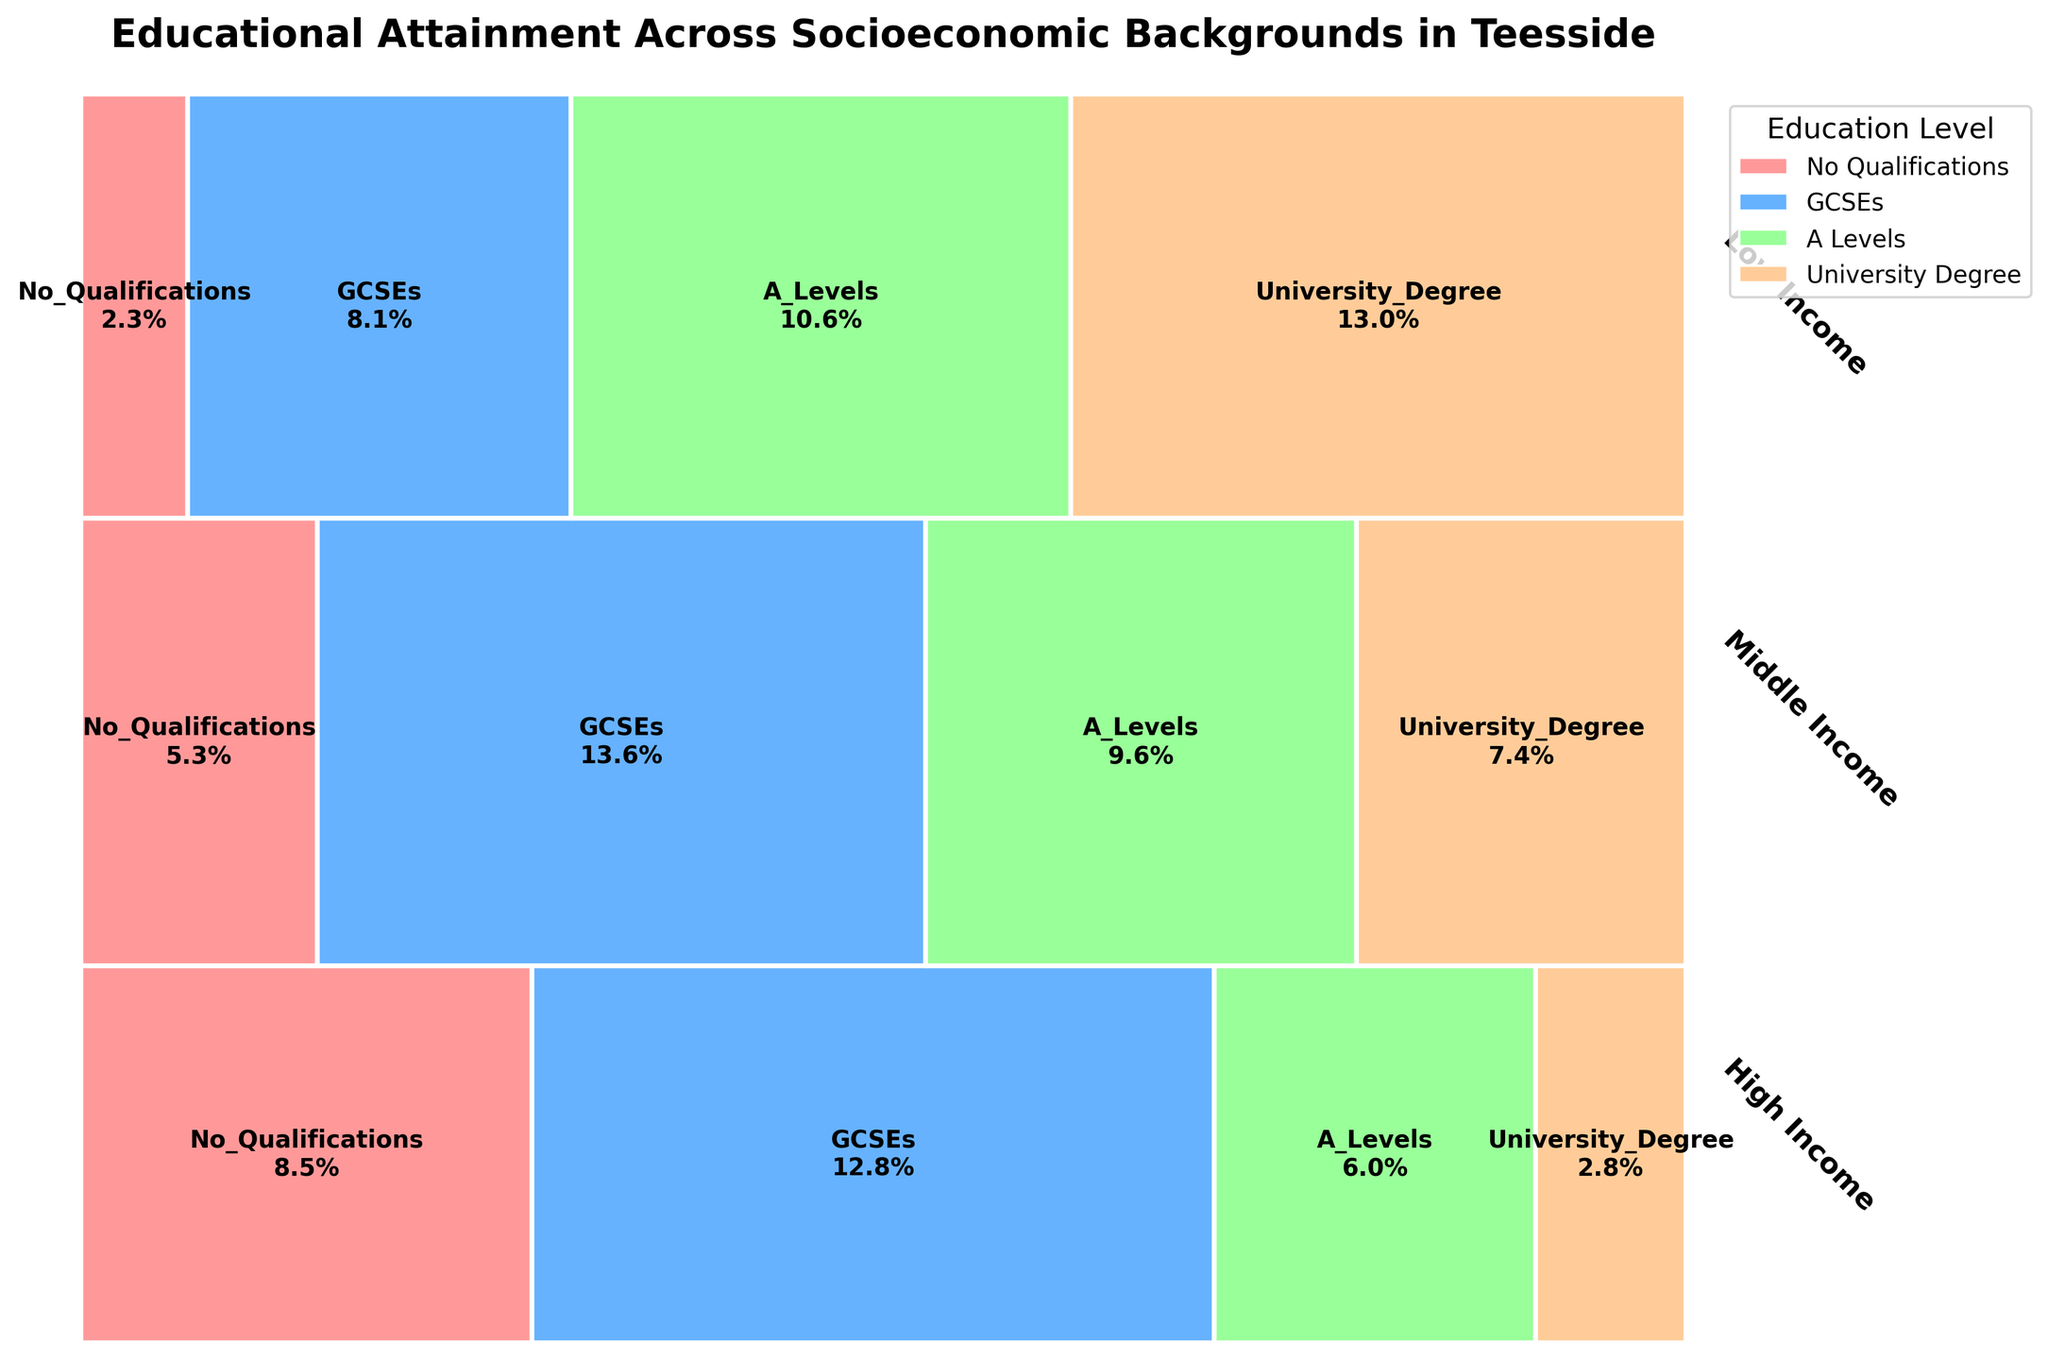What is the title of the figure? The title is usually placed at the top of the figure and it helps to provide an immediate understanding of what the figure represents.
Answer: Educational Attainment Across Socioeconomic Backgrounds in Teesside Which socioeconomic background has the highest proportion of people with university degrees? To determine this, look at the part of the mosaic plot corresponding to 'University_Degree' for each socioeconomic background and identify which one has the longest bar.
Answer: High Income How does the proportion of people with no qualifications compare between low and high-income backgrounds? Compare the lengths of the 'No_Qualifications' sections for low and high-income backgrounds to see which one is longer.
Answer: Low income has a higher proportion of people with no qualifications What percentage of individuals from middle-income backgrounds have A-Levels? Find the 'A_Levels' section within the middle-income background segment and read the percentage provided on the figure.
Answer: 7.1% Which education level appears least frequently among low-income backgrounds? Identify the shortest section within the low-income background in the mosaic plot to determine which education level has the smallest percentage.
Answer: University Degree What is the total proportion of people with GCSEs across all socioeconomic backgrounds? Add up the proportions of people with 'GCSEs' from all three socioeconomic backgrounds to get the total proportion. This requires summing the percentages directly from the plot.
Answer: 18.3% Does any socioeconomic background have a higher proportion of individuals with A-Levels than with GCSEs? Check the lengths of the bars corresponding to 'A_Levels' and 'GCSEs' for each socioeconomic background and compare them.
Answer: No Are the proportions of people with university degrees and no qualifications equal for any of the socioeconomic backgrounds? Compare the proportions of 'University_Degree' and 'No_Qualifications' for each socioeconomic background to see if any of them are equal.
Answer: No Which socioeconomic background has the smallest proportion of individuals with A-Levels? Look at the 'A_Levels' section for each socioeconomic background and identify which one has the smallest proportion.
Answer: Low Income 